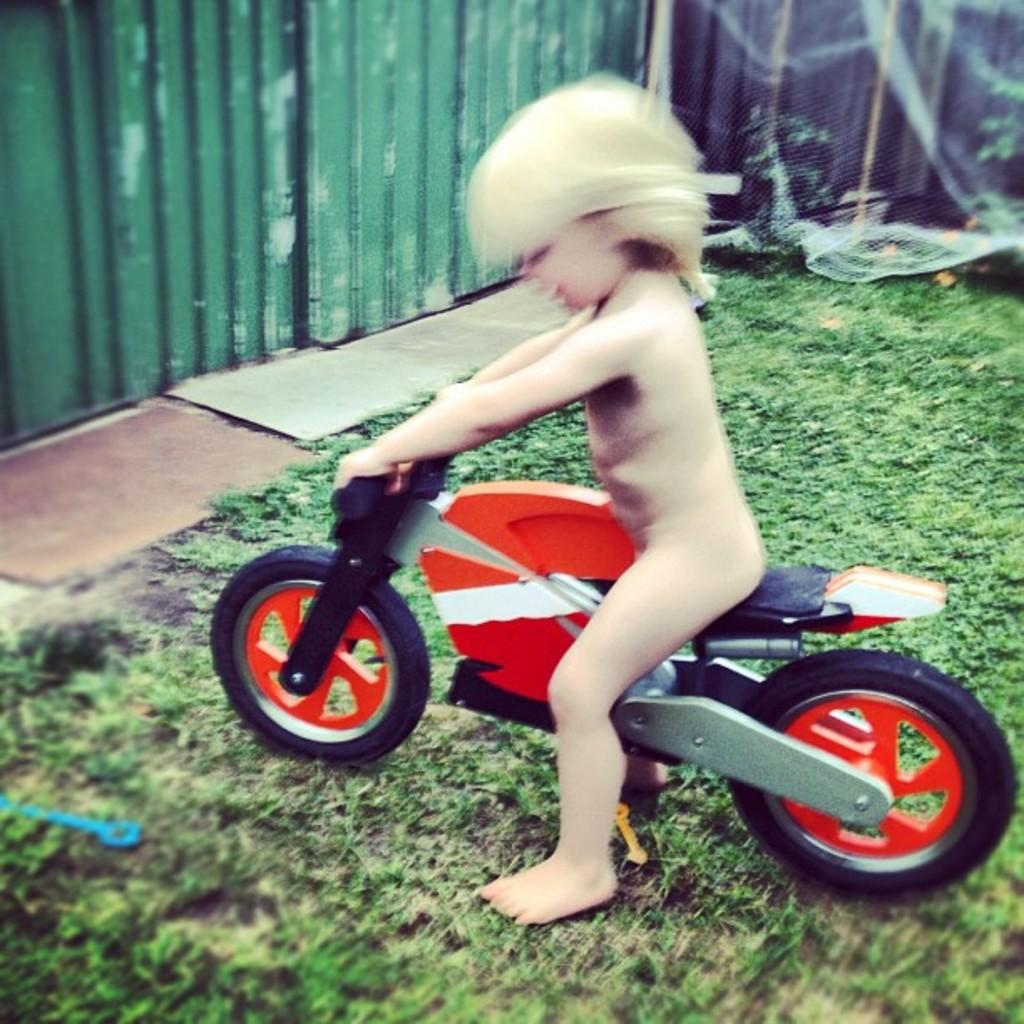Who is the main subject in the image? There is a small girl in the image. What is the girl doing in the image? The girl is sitting and riding a red toy bike. Where is the scene taking place? The scene takes place in a lawn. What can be seen in the background of the image? There is a green color iron shed and a white net in the background. How many brothers does the girl have in the image? There is no information about the girl's brothers in the image. What type of birds can be seen flying in the image? There are no birds visible in the image. 